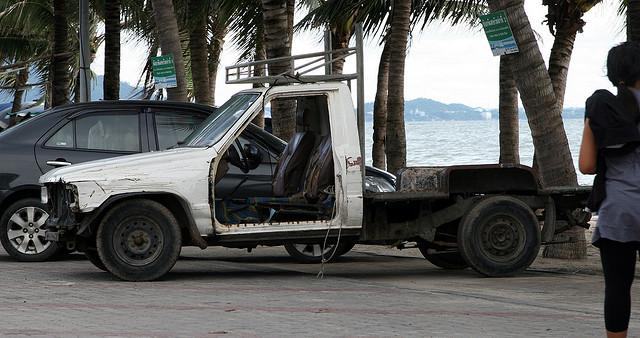What is the truck missing that would make it illegal in many countries?

Choices:
A) truck bed
B) tires
C) tail gate
D) doors doors 